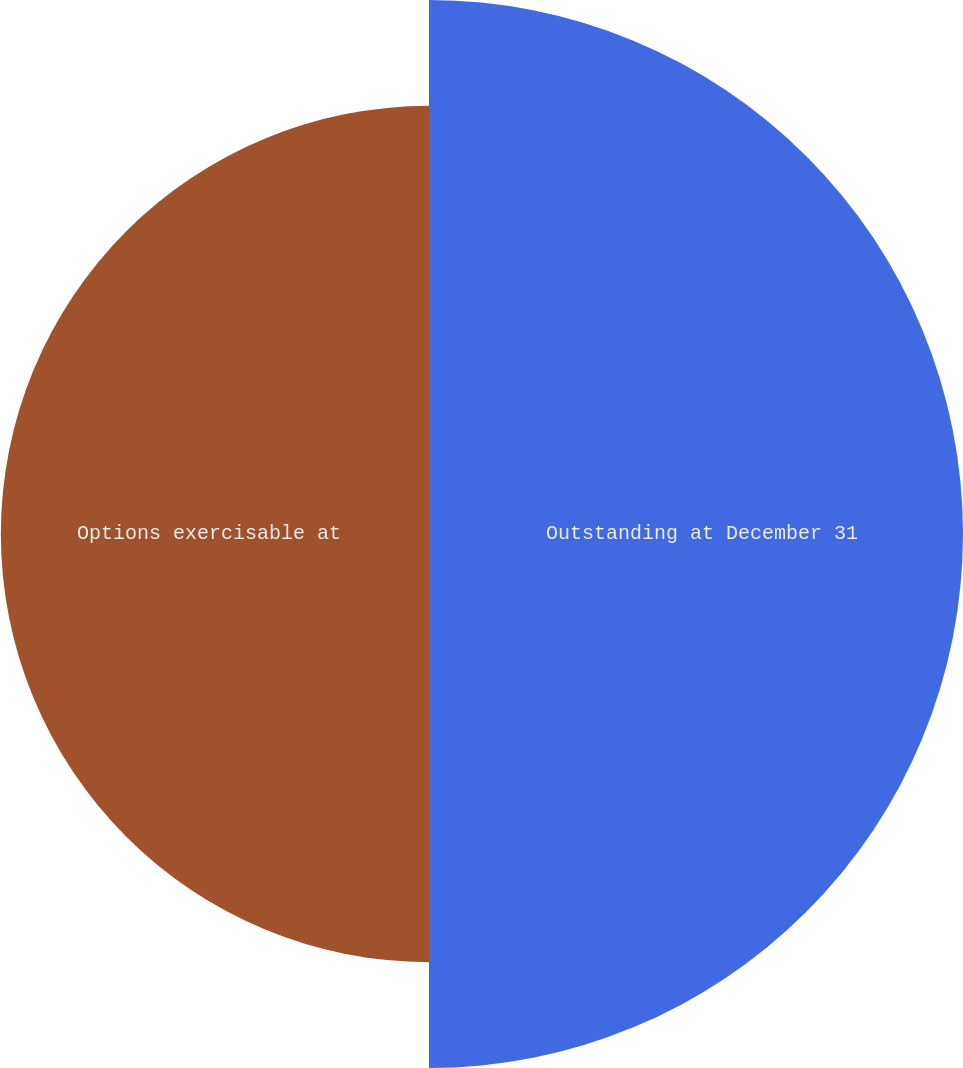<chart> <loc_0><loc_0><loc_500><loc_500><pie_chart><fcel>Outstanding at December 31<fcel>Options exercisable at<nl><fcel>55.5%<fcel>44.5%<nl></chart> 